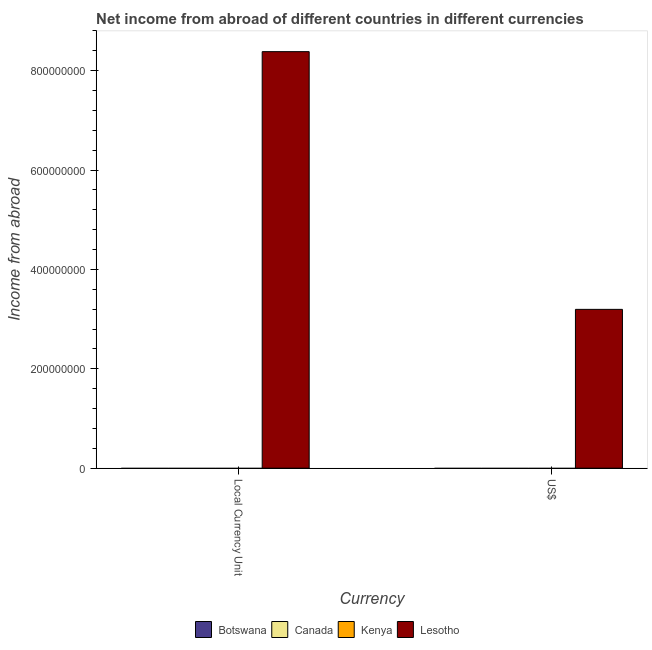How many different coloured bars are there?
Offer a terse response. 1. Are the number of bars per tick equal to the number of legend labels?
Your response must be concise. No. Are the number of bars on each tick of the X-axis equal?
Your answer should be very brief. Yes. How many bars are there on the 2nd tick from the left?
Your response must be concise. 1. How many bars are there on the 1st tick from the right?
Provide a short and direct response. 1. What is the label of the 2nd group of bars from the left?
Your response must be concise. US$. What is the income from abroad in us$ in Kenya?
Your answer should be compact. 0. Across all countries, what is the maximum income from abroad in constant 2005 us$?
Provide a succinct answer. 8.38e+08. Across all countries, what is the minimum income from abroad in us$?
Keep it short and to the point. 0. In which country was the income from abroad in us$ maximum?
Your answer should be very brief. Lesotho. What is the total income from abroad in constant 2005 us$ in the graph?
Your response must be concise. 8.38e+08. What is the average income from abroad in us$ per country?
Make the answer very short. 7.99e+07. What is the difference between the income from abroad in constant 2005 us$ and income from abroad in us$ in Lesotho?
Your answer should be very brief. 5.19e+08. In how many countries, is the income from abroad in constant 2005 us$ greater than the average income from abroad in constant 2005 us$ taken over all countries?
Keep it short and to the point. 1. Are all the bars in the graph horizontal?
Make the answer very short. No. What is the difference between two consecutive major ticks on the Y-axis?
Ensure brevity in your answer.  2.00e+08. Does the graph contain grids?
Make the answer very short. No. How many legend labels are there?
Make the answer very short. 4. How are the legend labels stacked?
Provide a succinct answer. Horizontal. What is the title of the graph?
Ensure brevity in your answer.  Net income from abroad of different countries in different currencies. Does "Russian Federation" appear as one of the legend labels in the graph?
Your answer should be very brief. No. What is the label or title of the X-axis?
Your answer should be compact. Currency. What is the label or title of the Y-axis?
Your answer should be very brief. Income from abroad. What is the Income from abroad in Botswana in Local Currency Unit?
Give a very brief answer. 0. What is the Income from abroad of Canada in Local Currency Unit?
Give a very brief answer. 0. What is the Income from abroad in Lesotho in Local Currency Unit?
Keep it short and to the point. 8.38e+08. What is the Income from abroad in Kenya in US$?
Your answer should be very brief. 0. What is the Income from abroad in Lesotho in US$?
Ensure brevity in your answer.  3.20e+08. Across all Currency, what is the maximum Income from abroad of Lesotho?
Provide a short and direct response. 8.38e+08. Across all Currency, what is the minimum Income from abroad of Lesotho?
Make the answer very short. 3.20e+08. What is the total Income from abroad of Kenya in the graph?
Provide a succinct answer. 0. What is the total Income from abroad of Lesotho in the graph?
Your answer should be very brief. 1.16e+09. What is the difference between the Income from abroad in Lesotho in Local Currency Unit and that in US$?
Offer a terse response. 5.19e+08. What is the average Income from abroad of Kenya per Currency?
Make the answer very short. 0. What is the average Income from abroad of Lesotho per Currency?
Make the answer very short. 5.79e+08. What is the ratio of the Income from abroad in Lesotho in Local Currency Unit to that in US$?
Your answer should be compact. 2.62. What is the difference between the highest and the second highest Income from abroad of Lesotho?
Make the answer very short. 5.19e+08. What is the difference between the highest and the lowest Income from abroad of Lesotho?
Ensure brevity in your answer.  5.19e+08. 